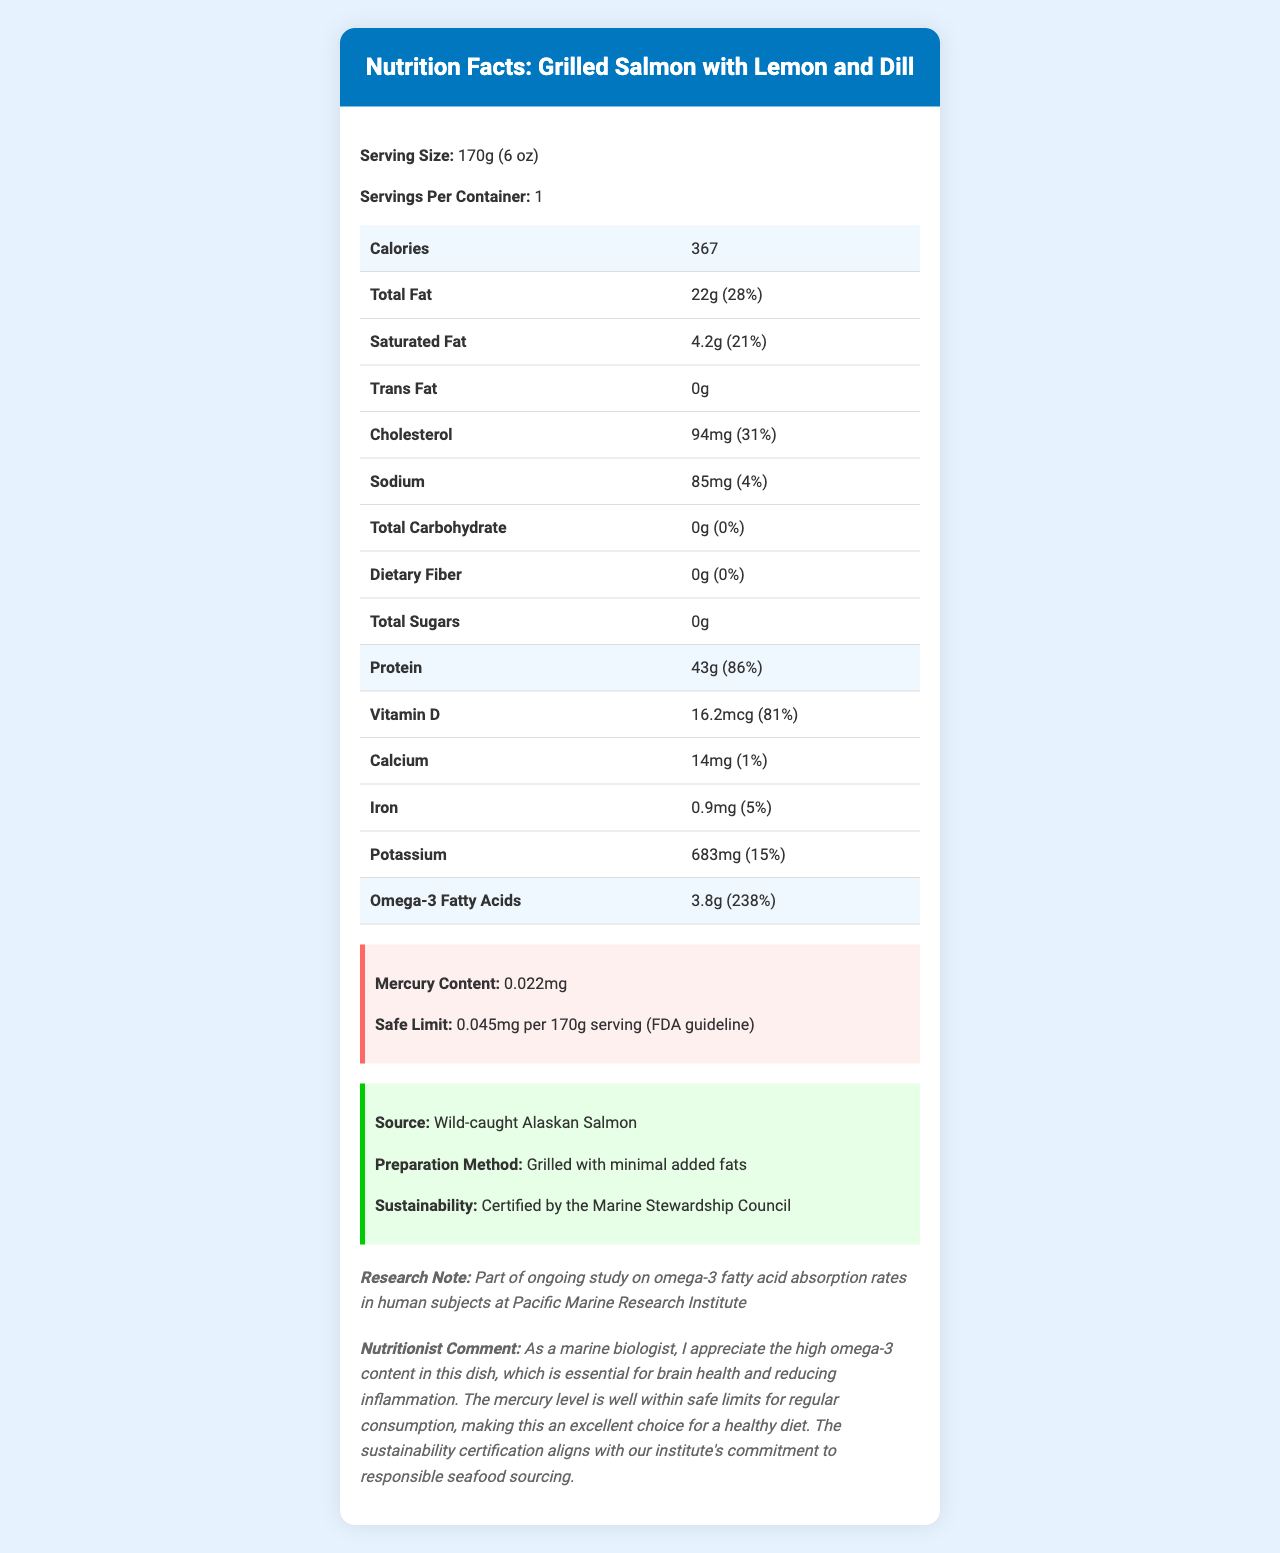what is the serving size? The serving size is clearly listed as "170g (6 oz)" at the top of the document.
Answer: 170g (6 oz) how many calories are in a serving of Grilled Salmon with Lemon and Dill? The calories per serving are listed in the highlighted section of the document.
Answer: 367 what is the total amount of omega-3 fatty acids in one serving of this dish? The omega-3 fatty acids are listed under the nutritional breakdown, with the amount provided as 3.8g.
Answer: 3.8g is the mercury content of this dish within the FDA's safe limit? The mercury content is listed as 0.022mg, and the safe limit according to the FDA guideline is 0.045mg per 170g serving, making it within the safe limit.
Answer: Yes what is the source of the salmon used in this dish? The source is mentioned under "Additional Info" as "Wild-caught Alaskan Salmon."
Answer: Wild-caught Alaskan Salmon how does this dish contribute to daily Vitamin D requirements? A. 50% B. 81% C. 100% D. 120% The daily value for Vitamin D is noted as 81% in the nutritional information.
Answer: B which micronutrient has the highest daily value percentage in this dish? A. Iron B. Potassium C. Vitamin D D. Omega-3 fatty acids Omega-3 fatty acids have a daily value percentage of 238%, the highest among the listed micronutrients.
Answer: D does the dish contain trans fat? The document lists "Trans Fat: 0g," indicating it does not contain trans fat.
Answer: No summarize the main nutritional benefits of this dish. The dish offers 43g of protein (86% of daily value), 3.8g of omega-3 fatty acids (238% of daily value), and a safe level of mercury, making it a healthy option.
Answer: High in protein, high in omega-3 fatty acids, and low mercury content. can the sustainability certification of the salmon be verified from the document? The document mentions that the salmon is certified by the Marine Stewardship Council, ensuring its sustainability.
Answer: Yes what is the saturated fat content in one serving, and how does it compare to the daily recommended value? The saturated fat content is provided as 4.2g, which is 21% of the daily recommended value, indicating moderate consumption.
Answer: 4.2g (21% of daily value) what is the preparation method for the salmon, according to the document? The preparation method is specified in the additional information section.
Answer: Grilled with minimal added fats how many servings does the container provide? The servings per container are listed as 1 at the top of the nutrition facts.
Answer: 1 what ongoing study is this dish part of, as described in the document? The research note mentions that this dish is part of a study on omega-3 fatty acid absorption rates conducted at the Pacific Marine Research Institute.
Answer: Study on omega-3 fatty acid absorption rates in human subjects at Pacific Marine Research Institute what is the total carbohydrate amount in one serving, and how does it contribute to daily value? The document lists the total carbohydrate amount as 0g, contributing 0% to the daily value.
Answer: 0g (0% of daily value) does the dish contain any dietary fiber? The document lists "Dietary Fiber: 0g" under the nutritional breakdown, indicating no dietary fiber content.
Answer: No how much potassium does one serving contain? The potassium content per serving is listed as 683mg in the nutrition information.
Answer: 683mg what is the amount of calcium in this dish? The calcium amount for one serving is listed as 14mg in the nutritional breakdown.
Answer: 14mg who provided the nutritionist comment included in the document? The document includes a nutritionist comment, but it does not specify who provided it.
Answer: I don't know 